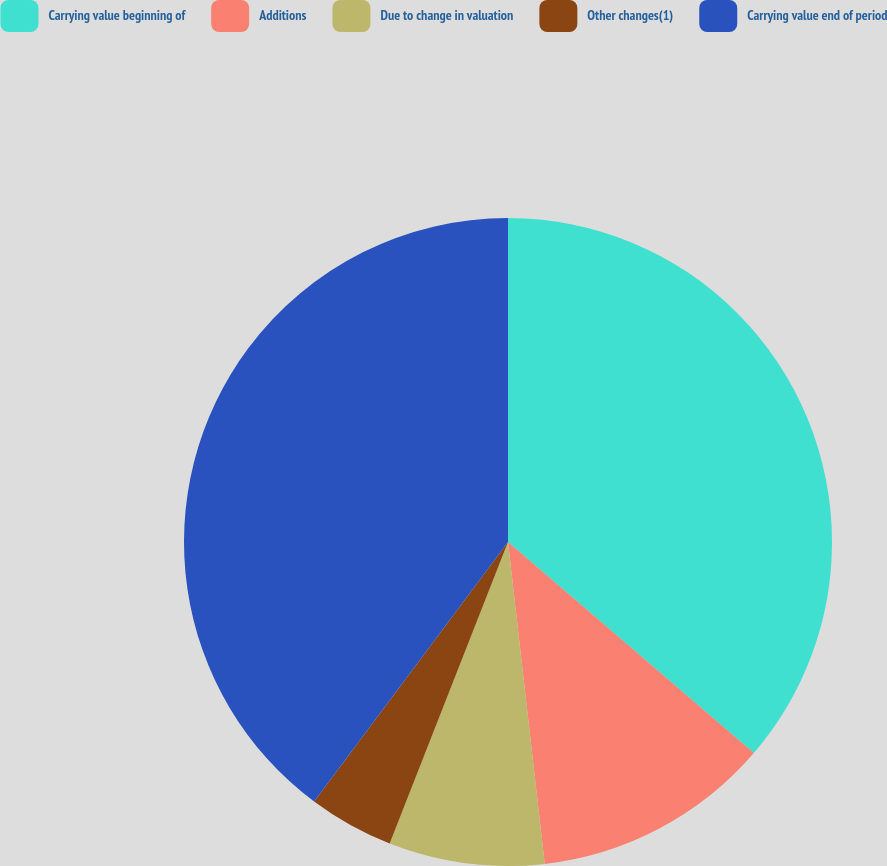<chart> <loc_0><loc_0><loc_500><loc_500><pie_chart><fcel>Carrying value beginning of<fcel>Additions<fcel>Due to change in valuation<fcel>Other changes(1)<fcel>Carrying value end of period<nl><fcel>36.29%<fcel>11.9%<fcel>7.76%<fcel>4.26%<fcel>39.79%<nl></chart> 